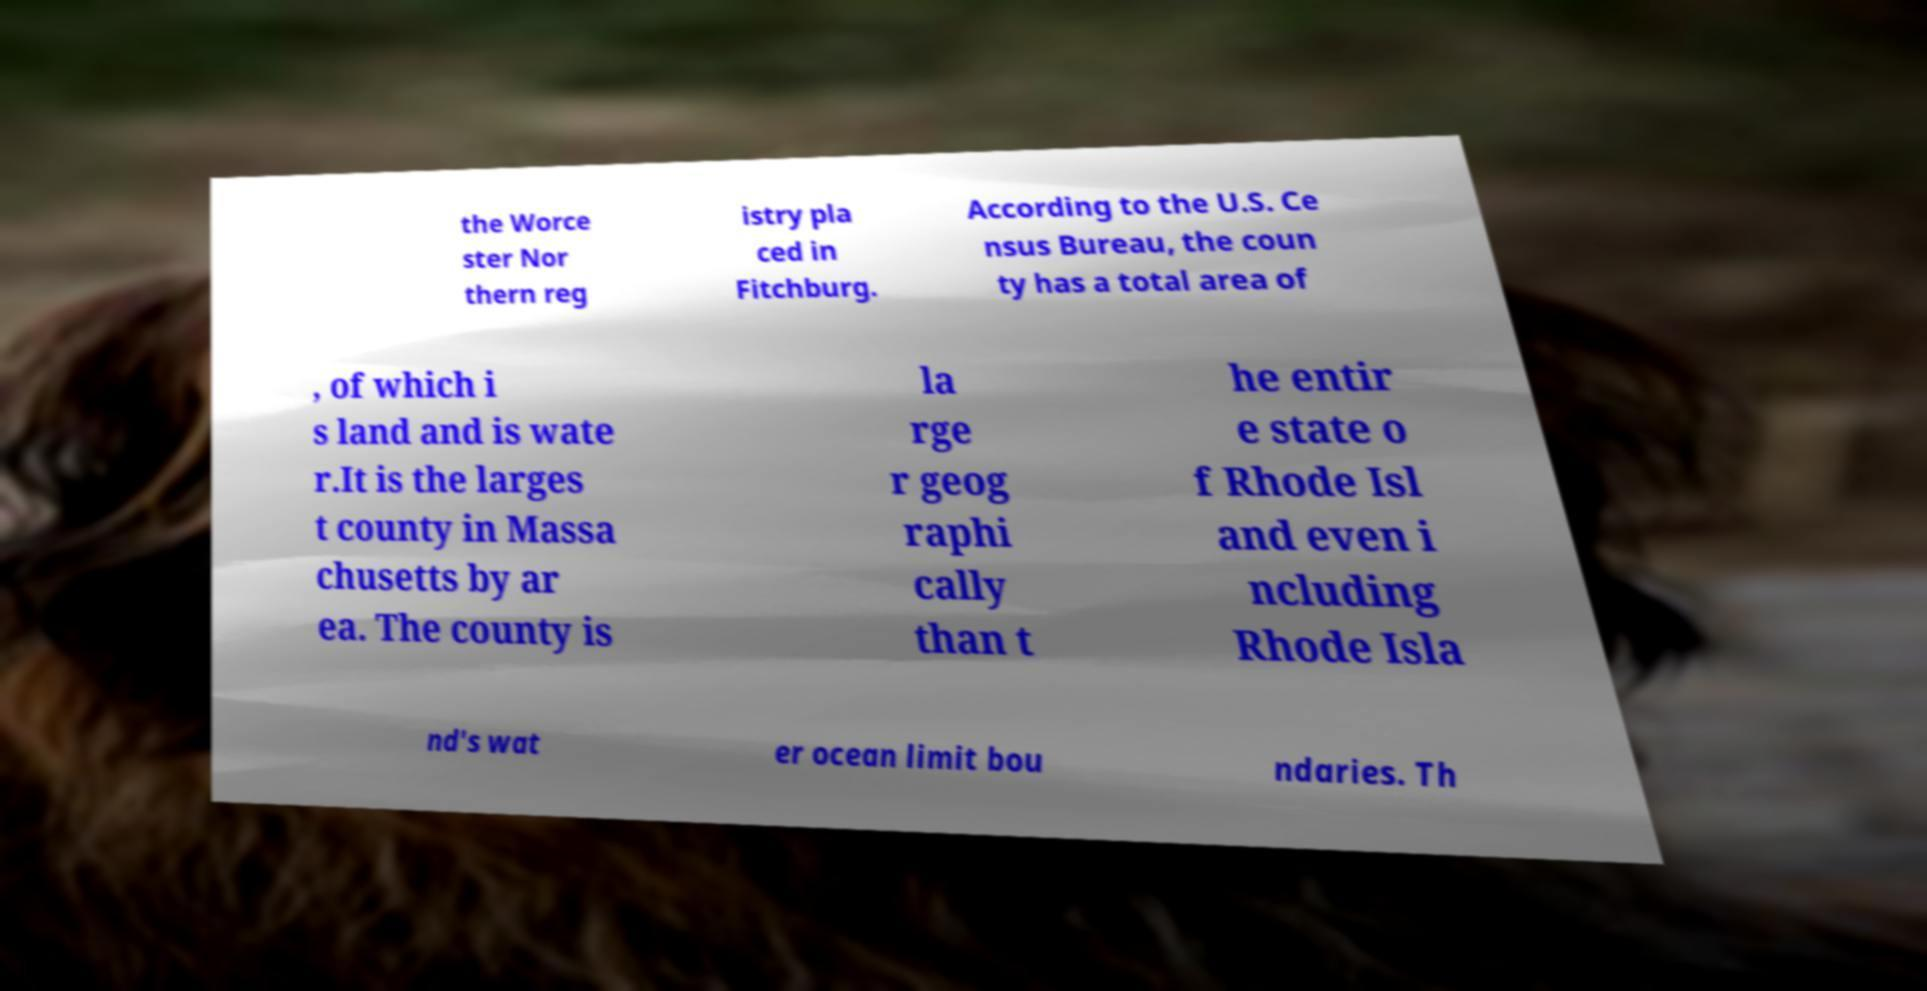Could you assist in decoding the text presented in this image and type it out clearly? the Worce ster Nor thern reg istry pla ced in Fitchburg. According to the U.S. Ce nsus Bureau, the coun ty has a total area of , of which i s land and is wate r.It is the larges t county in Massa chusetts by ar ea. The county is la rge r geog raphi cally than t he entir e state o f Rhode Isl and even i ncluding Rhode Isla nd's wat er ocean limit bou ndaries. Th 